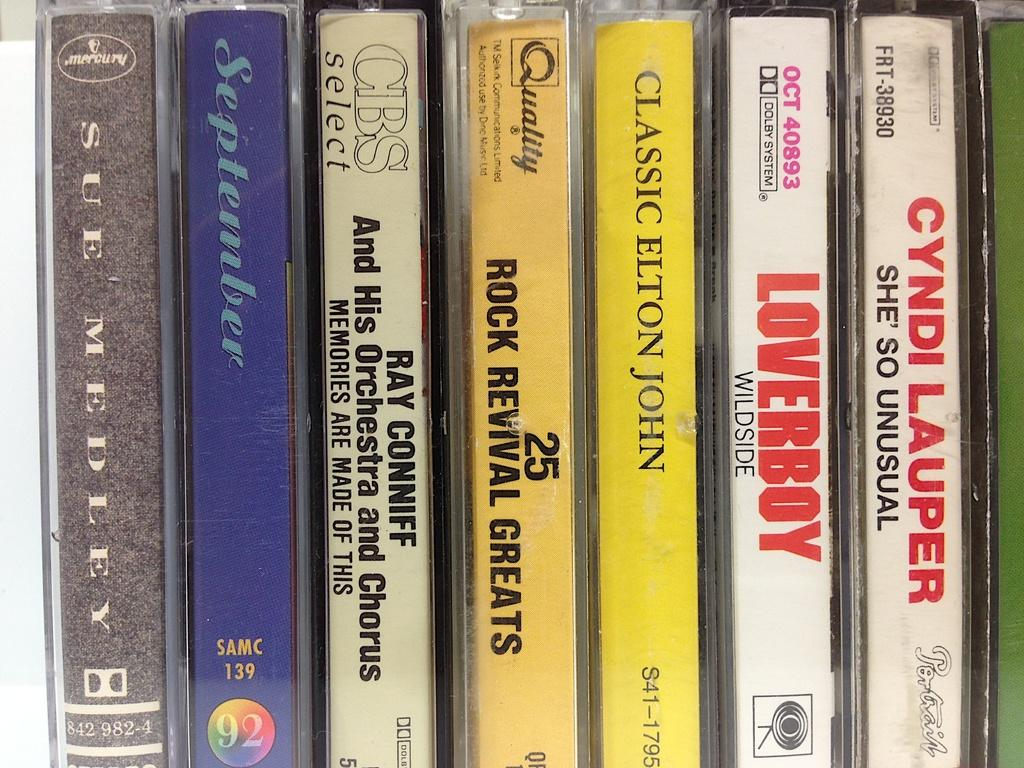<image>
Relay a brief, clear account of the picture shown. A row of cassette tapes including Classic Elton John. 